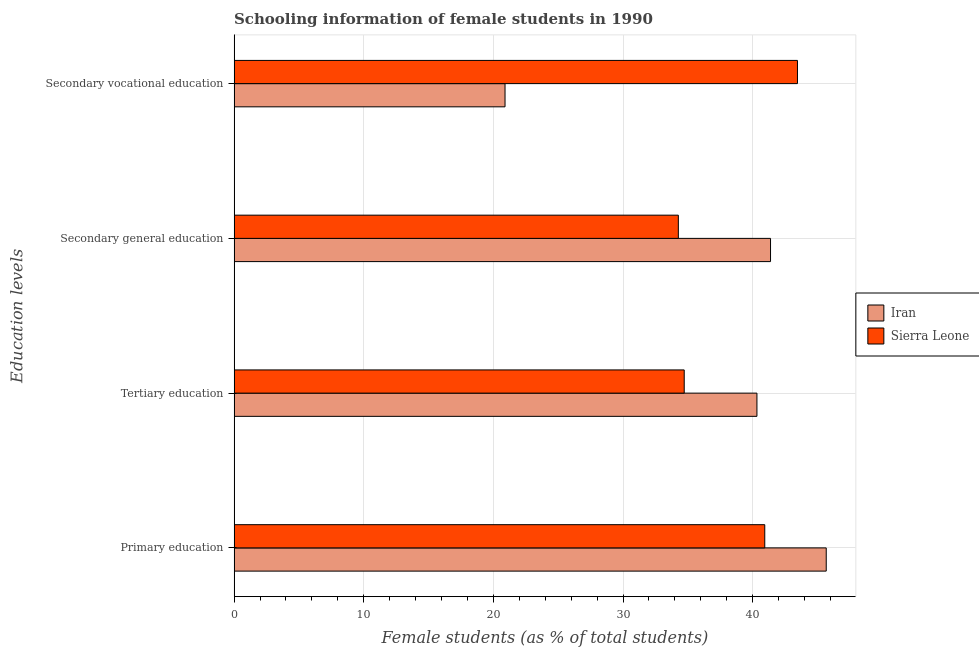How many different coloured bars are there?
Ensure brevity in your answer.  2. How many groups of bars are there?
Give a very brief answer. 4. Are the number of bars per tick equal to the number of legend labels?
Provide a short and direct response. Yes. What is the label of the 4th group of bars from the top?
Provide a succinct answer. Primary education. What is the percentage of female students in secondary education in Sierra Leone?
Keep it short and to the point. 34.26. Across all countries, what is the maximum percentage of female students in primary education?
Your response must be concise. 45.67. Across all countries, what is the minimum percentage of female students in tertiary education?
Offer a terse response. 34.72. In which country was the percentage of female students in tertiary education maximum?
Your answer should be compact. Iran. In which country was the percentage of female students in secondary education minimum?
Offer a terse response. Sierra Leone. What is the total percentage of female students in secondary education in the graph?
Ensure brevity in your answer.  75.64. What is the difference between the percentage of female students in secondary vocational education in Sierra Leone and that in Iran?
Provide a succinct answer. 22.56. What is the difference between the percentage of female students in primary education in Sierra Leone and the percentage of female students in secondary education in Iran?
Keep it short and to the point. -0.44. What is the average percentage of female students in secondary education per country?
Offer a very short reply. 37.82. What is the difference between the percentage of female students in secondary education and percentage of female students in secondary vocational education in Sierra Leone?
Offer a very short reply. -9.19. In how many countries, is the percentage of female students in tertiary education greater than 30 %?
Provide a succinct answer. 2. What is the ratio of the percentage of female students in primary education in Iran to that in Sierra Leone?
Make the answer very short. 1.12. Is the difference between the percentage of female students in secondary vocational education in Sierra Leone and Iran greater than the difference between the percentage of female students in primary education in Sierra Leone and Iran?
Make the answer very short. Yes. What is the difference between the highest and the second highest percentage of female students in tertiary education?
Offer a terse response. 5.61. What is the difference between the highest and the lowest percentage of female students in secondary education?
Your answer should be compact. 7.11. In how many countries, is the percentage of female students in tertiary education greater than the average percentage of female students in tertiary education taken over all countries?
Your answer should be very brief. 1. Is the sum of the percentage of female students in secondary education in Iran and Sierra Leone greater than the maximum percentage of female students in secondary vocational education across all countries?
Your response must be concise. Yes. What does the 2nd bar from the top in Secondary vocational education represents?
Your answer should be very brief. Iran. What does the 2nd bar from the bottom in Tertiary education represents?
Provide a short and direct response. Sierra Leone. Is it the case that in every country, the sum of the percentage of female students in primary education and percentage of female students in tertiary education is greater than the percentage of female students in secondary education?
Give a very brief answer. Yes. Are all the bars in the graph horizontal?
Offer a terse response. Yes. How many countries are there in the graph?
Your response must be concise. 2. Are the values on the major ticks of X-axis written in scientific E-notation?
Your answer should be compact. No. Does the graph contain any zero values?
Make the answer very short. No. Where does the legend appear in the graph?
Make the answer very short. Center right. How many legend labels are there?
Give a very brief answer. 2. What is the title of the graph?
Your response must be concise. Schooling information of female students in 1990. Does "Lao PDR" appear as one of the legend labels in the graph?
Make the answer very short. No. What is the label or title of the X-axis?
Keep it short and to the point. Female students (as % of total students). What is the label or title of the Y-axis?
Offer a very short reply. Education levels. What is the Female students (as % of total students) of Iran in Primary education?
Provide a succinct answer. 45.67. What is the Female students (as % of total students) of Sierra Leone in Primary education?
Your response must be concise. 40.93. What is the Female students (as % of total students) in Iran in Tertiary education?
Your answer should be very brief. 40.33. What is the Female students (as % of total students) of Sierra Leone in Tertiary education?
Offer a very short reply. 34.72. What is the Female students (as % of total students) in Iran in Secondary general education?
Provide a short and direct response. 41.37. What is the Female students (as % of total students) of Sierra Leone in Secondary general education?
Make the answer very short. 34.26. What is the Female students (as % of total students) in Iran in Secondary vocational education?
Ensure brevity in your answer.  20.9. What is the Female students (as % of total students) in Sierra Leone in Secondary vocational education?
Your answer should be compact. 43.45. Across all Education levels, what is the maximum Female students (as % of total students) in Iran?
Keep it short and to the point. 45.67. Across all Education levels, what is the maximum Female students (as % of total students) in Sierra Leone?
Your answer should be very brief. 43.45. Across all Education levels, what is the minimum Female students (as % of total students) in Iran?
Your response must be concise. 20.9. Across all Education levels, what is the minimum Female students (as % of total students) of Sierra Leone?
Ensure brevity in your answer.  34.26. What is the total Female students (as % of total students) of Iran in the graph?
Offer a terse response. 148.27. What is the total Female students (as % of total students) in Sierra Leone in the graph?
Your answer should be very brief. 153.36. What is the difference between the Female students (as % of total students) of Iran in Primary education and that in Tertiary education?
Ensure brevity in your answer.  5.34. What is the difference between the Female students (as % of total students) in Sierra Leone in Primary education and that in Tertiary education?
Offer a terse response. 6.21. What is the difference between the Female students (as % of total students) of Iran in Primary education and that in Secondary general education?
Offer a terse response. 4.3. What is the difference between the Female students (as % of total students) in Sierra Leone in Primary education and that in Secondary general education?
Give a very brief answer. 6.67. What is the difference between the Female students (as % of total students) of Iran in Primary education and that in Secondary vocational education?
Your answer should be very brief. 24.77. What is the difference between the Female students (as % of total students) in Sierra Leone in Primary education and that in Secondary vocational education?
Provide a succinct answer. -2.52. What is the difference between the Female students (as % of total students) in Iran in Tertiary education and that in Secondary general education?
Ensure brevity in your answer.  -1.05. What is the difference between the Female students (as % of total students) of Sierra Leone in Tertiary education and that in Secondary general education?
Keep it short and to the point. 0.45. What is the difference between the Female students (as % of total students) in Iran in Tertiary education and that in Secondary vocational education?
Your answer should be compact. 19.43. What is the difference between the Female students (as % of total students) in Sierra Leone in Tertiary education and that in Secondary vocational education?
Your answer should be compact. -8.73. What is the difference between the Female students (as % of total students) in Iran in Secondary general education and that in Secondary vocational education?
Offer a terse response. 20.48. What is the difference between the Female students (as % of total students) in Sierra Leone in Secondary general education and that in Secondary vocational education?
Keep it short and to the point. -9.19. What is the difference between the Female students (as % of total students) of Iran in Primary education and the Female students (as % of total students) of Sierra Leone in Tertiary education?
Provide a short and direct response. 10.95. What is the difference between the Female students (as % of total students) in Iran in Primary education and the Female students (as % of total students) in Sierra Leone in Secondary general education?
Keep it short and to the point. 11.41. What is the difference between the Female students (as % of total students) in Iran in Primary education and the Female students (as % of total students) in Sierra Leone in Secondary vocational education?
Your answer should be compact. 2.22. What is the difference between the Female students (as % of total students) in Iran in Tertiary education and the Female students (as % of total students) in Sierra Leone in Secondary general education?
Provide a short and direct response. 6.06. What is the difference between the Female students (as % of total students) of Iran in Tertiary education and the Female students (as % of total students) of Sierra Leone in Secondary vocational education?
Ensure brevity in your answer.  -3.13. What is the difference between the Female students (as % of total students) of Iran in Secondary general education and the Female students (as % of total students) of Sierra Leone in Secondary vocational education?
Provide a short and direct response. -2.08. What is the average Female students (as % of total students) in Iran per Education levels?
Ensure brevity in your answer.  37.07. What is the average Female students (as % of total students) of Sierra Leone per Education levels?
Your response must be concise. 38.34. What is the difference between the Female students (as % of total students) in Iran and Female students (as % of total students) in Sierra Leone in Primary education?
Ensure brevity in your answer.  4.74. What is the difference between the Female students (as % of total students) of Iran and Female students (as % of total students) of Sierra Leone in Tertiary education?
Offer a very short reply. 5.61. What is the difference between the Female students (as % of total students) in Iran and Female students (as % of total students) in Sierra Leone in Secondary general education?
Ensure brevity in your answer.  7.11. What is the difference between the Female students (as % of total students) of Iran and Female students (as % of total students) of Sierra Leone in Secondary vocational education?
Your response must be concise. -22.56. What is the ratio of the Female students (as % of total students) of Iran in Primary education to that in Tertiary education?
Provide a succinct answer. 1.13. What is the ratio of the Female students (as % of total students) of Sierra Leone in Primary education to that in Tertiary education?
Your answer should be very brief. 1.18. What is the ratio of the Female students (as % of total students) of Iran in Primary education to that in Secondary general education?
Make the answer very short. 1.1. What is the ratio of the Female students (as % of total students) in Sierra Leone in Primary education to that in Secondary general education?
Provide a succinct answer. 1.19. What is the ratio of the Female students (as % of total students) of Iran in Primary education to that in Secondary vocational education?
Your answer should be compact. 2.19. What is the ratio of the Female students (as % of total students) of Sierra Leone in Primary education to that in Secondary vocational education?
Your answer should be compact. 0.94. What is the ratio of the Female students (as % of total students) of Iran in Tertiary education to that in Secondary general education?
Give a very brief answer. 0.97. What is the ratio of the Female students (as % of total students) in Sierra Leone in Tertiary education to that in Secondary general education?
Offer a very short reply. 1.01. What is the ratio of the Female students (as % of total students) in Iran in Tertiary education to that in Secondary vocational education?
Ensure brevity in your answer.  1.93. What is the ratio of the Female students (as % of total students) of Sierra Leone in Tertiary education to that in Secondary vocational education?
Ensure brevity in your answer.  0.8. What is the ratio of the Female students (as % of total students) in Iran in Secondary general education to that in Secondary vocational education?
Provide a succinct answer. 1.98. What is the ratio of the Female students (as % of total students) of Sierra Leone in Secondary general education to that in Secondary vocational education?
Keep it short and to the point. 0.79. What is the difference between the highest and the second highest Female students (as % of total students) of Iran?
Keep it short and to the point. 4.3. What is the difference between the highest and the second highest Female students (as % of total students) of Sierra Leone?
Provide a short and direct response. 2.52. What is the difference between the highest and the lowest Female students (as % of total students) of Iran?
Keep it short and to the point. 24.77. What is the difference between the highest and the lowest Female students (as % of total students) in Sierra Leone?
Offer a terse response. 9.19. 